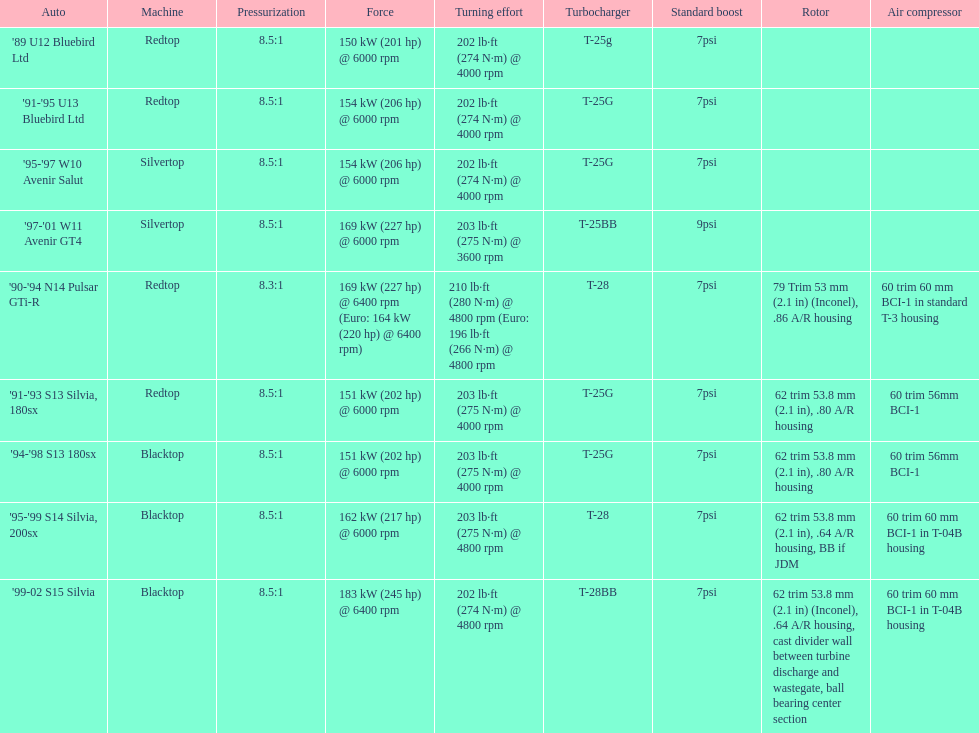Which engine has the smallest compression rate? '90-'94 N14 Pulsar GTi-R. 